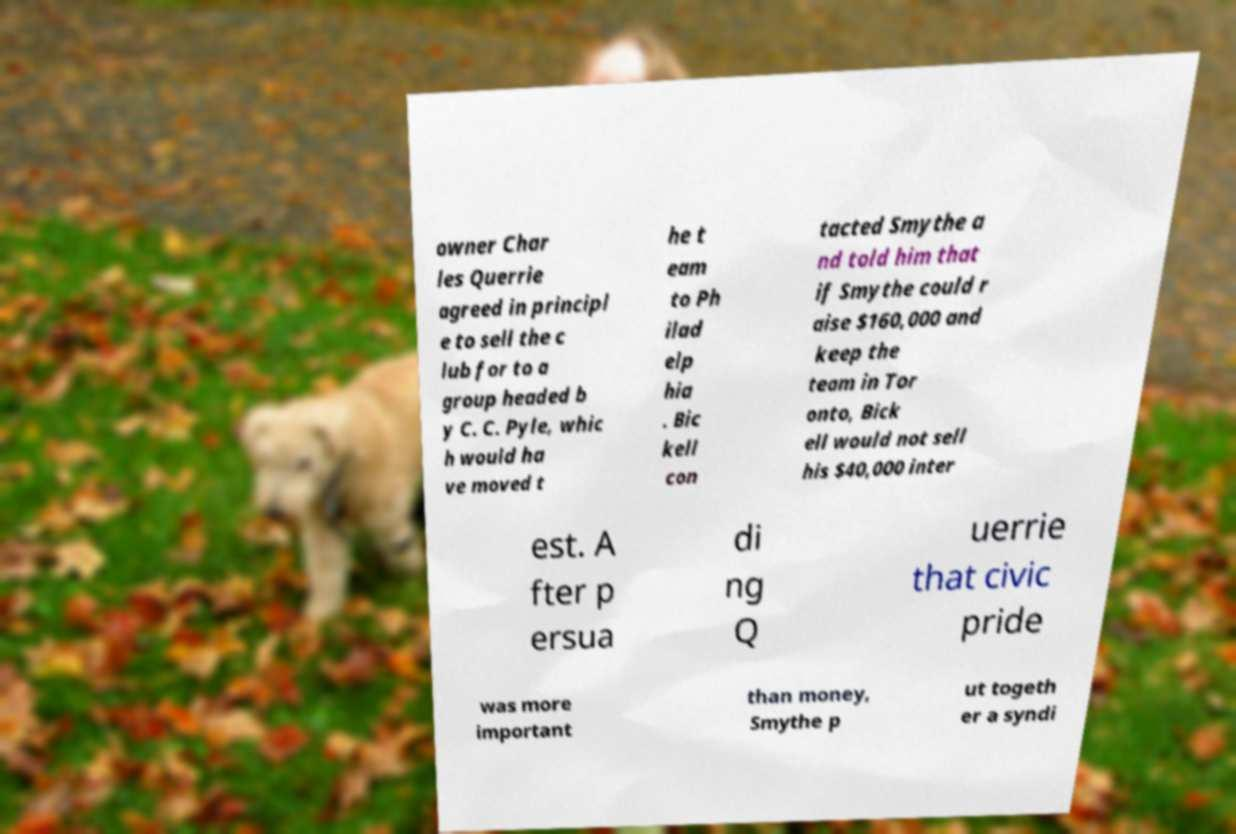Can you read and provide the text displayed in the image?This photo seems to have some interesting text. Can you extract and type it out for me? owner Char les Querrie agreed in principl e to sell the c lub for to a group headed b y C. C. Pyle, whic h would ha ve moved t he t eam to Ph ilad elp hia . Bic kell con tacted Smythe a nd told him that if Smythe could r aise $160,000 and keep the team in Tor onto, Bick ell would not sell his $40,000 inter est. A fter p ersua di ng Q uerrie that civic pride was more important than money, Smythe p ut togeth er a syndi 